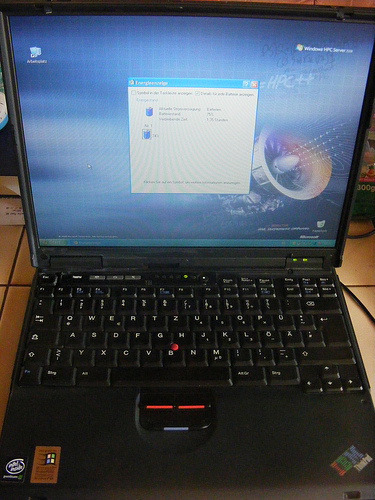<image>
Is there a laptop next to the wire? Yes. The laptop is positioned adjacent to the wire, located nearby in the same general area. Is the window above the computer? No. The window is not positioned above the computer. The vertical arrangement shows a different relationship. 